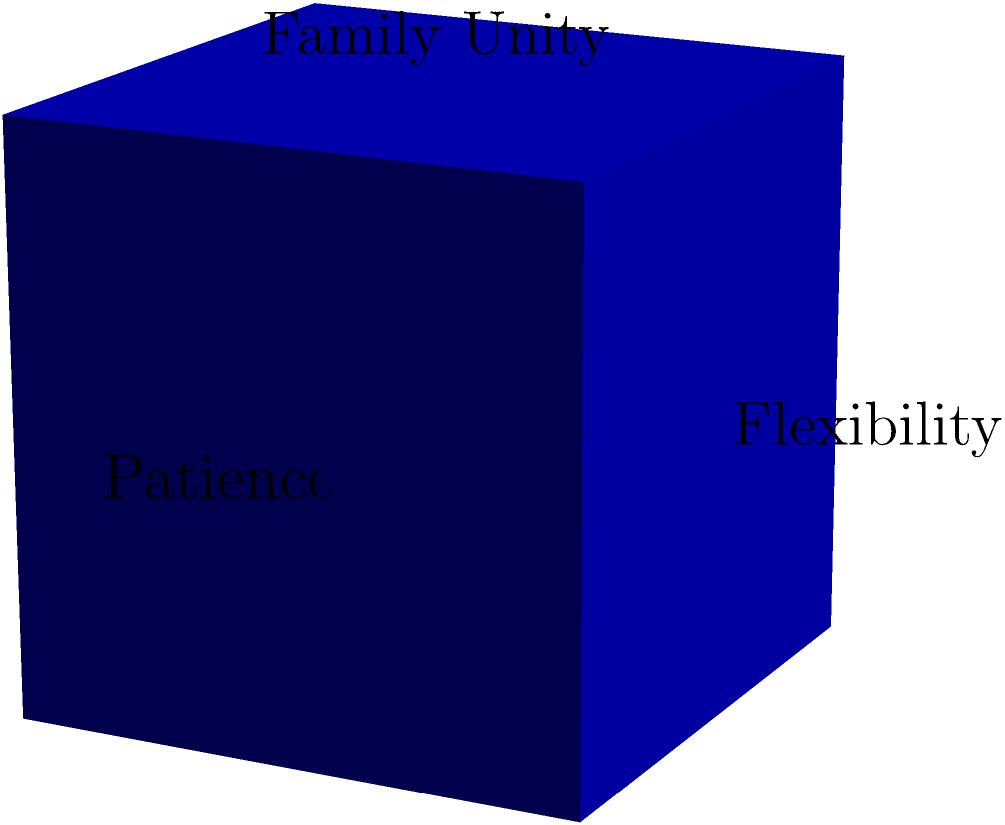A blended family is represented by a cube with side length 4 units. Each face of the cube symbolizes a different aspect of family life: Family Unity, Communication, Respect, Love, Patience, and Flexibility. If the family focuses on improving three adjacent faces (sharing a vertex) of the cube, what percentage of the total surface area are they addressing? Let's approach this step-by-step:

1) First, we need to calculate the surface area of one face of the cube:
   Area of one face = side length² = 4² = 16 square units

2) The total surface area of a cube is the area of all six faces:
   Total surface area = 6 × 16 = 96 square units

3) Three adjacent faces (sharing a vertex) would be half of the total faces:
   Area of three adjacent faces = 3 × 16 = 48 square units

4) To calculate the percentage, we use the formula:
   Percentage = (Part / Whole) × 100
               = (48 / 96) × 100
               = 0.5 × 100
               = 50%

Therefore, by focusing on three adjacent faces, the family is addressing 50% of the total surface area, symbolizing half of the aspects of their blended family dynamics.
Answer: 50% 